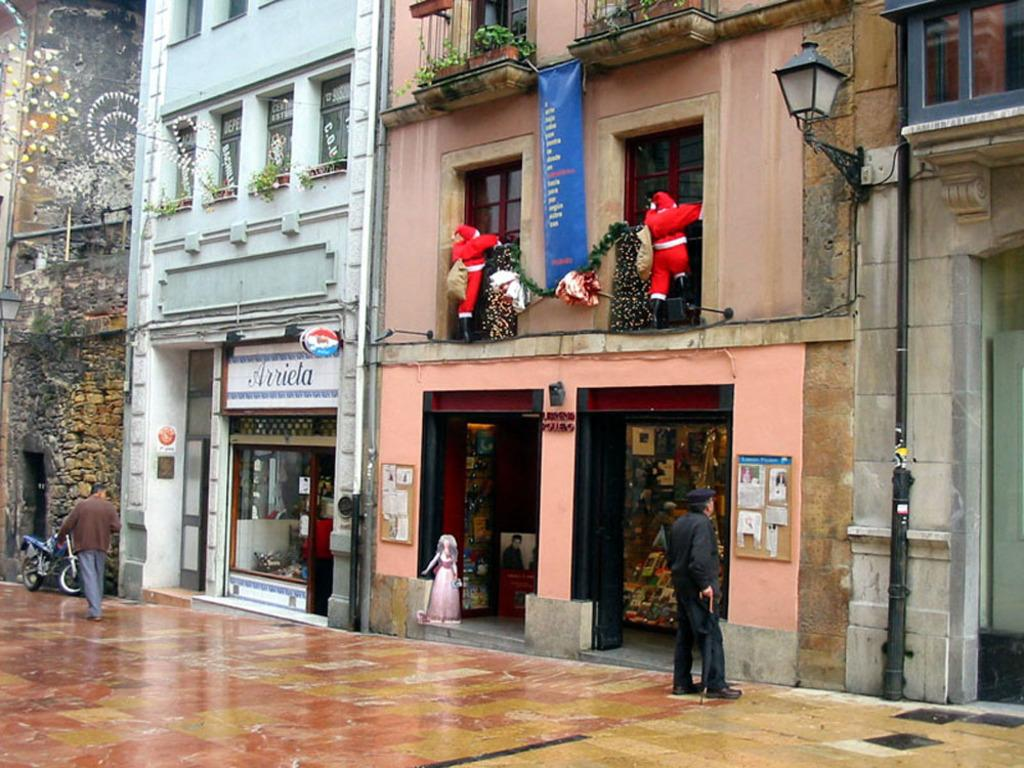What is located in the center of the image? There are buildings in the center of the image. Who or what can be seen at the bottom of the image? There are people at the bottom of the image. What type of establishments can be identified in the image? There are stores visible in the image. What objects are present in the image that emit light? There are lights visible in the image. What type of toys are featured in the image? There are dolls in the image. What advice is the oven giving to the branch in the image? There is no oven or branch present in the image, so no such interaction or advice can be observed. 